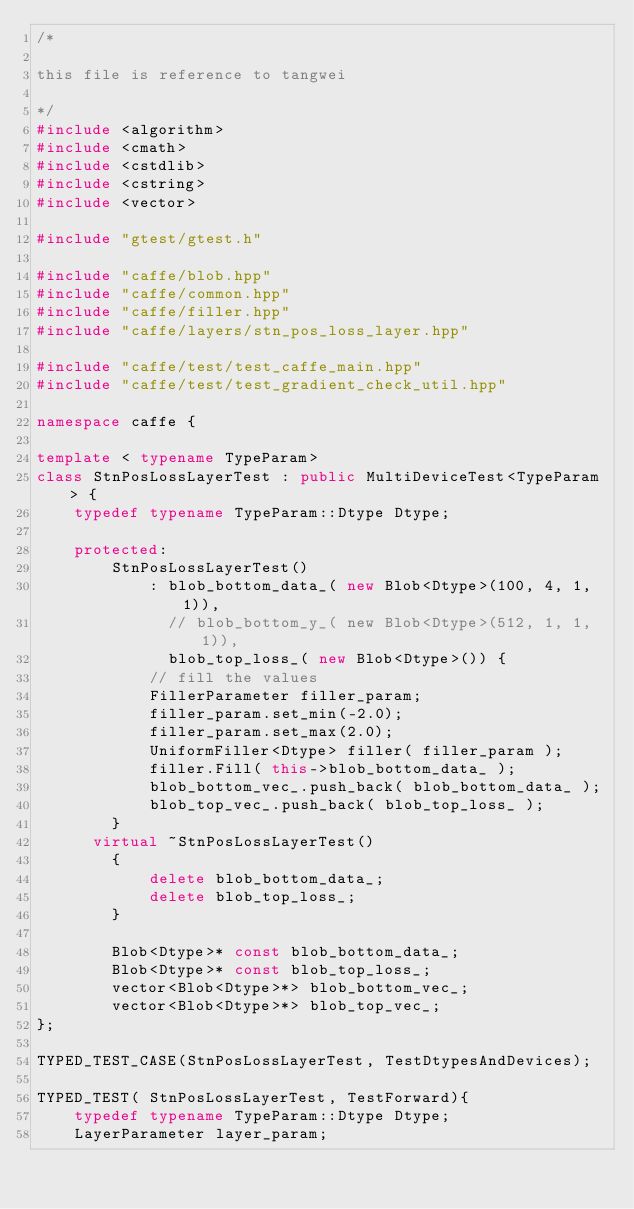Convert code to text. <code><loc_0><loc_0><loc_500><loc_500><_C++_>/*

this file is reference to tangwei

*/
#include <algorithm>
#include <cmath>
#include <cstdlib>
#include <cstring>
#include <vector>

#include "gtest/gtest.h"

#include "caffe/blob.hpp"
#include "caffe/common.hpp"
#include "caffe/filler.hpp"
#include "caffe/layers/stn_pos_loss_layer.hpp"

#include "caffe/test/test_caffe_main.hpp"
#include "caffe/test/test_gradient_check_util.hpp"

namespace caffe {

template < typename TypeParam>
class StnPosLossLayerTest : public MultiDeviceTest<TypeParam> {
    typedef typename TypeParam::Dtype Dtype;

    protected:
        StnPosLossLayerTest()
            : blob_bottom_data_( new Blob<Dtype>(100, 4, 1, 1)),
              // blob_bottom_y_( new Blob<Dtype>(512, 1, 1, 1)),
              blob_top_loss_( new Blob<Dtype>()) {
            // fill the values
            FillerParameter filler_param;
            filler_param.set_min(-2.0);
            filler_param.set_max(2.0);
            UniformFiller<Dtype> filler( filler_param );
            filler.Fill( this->blob_bottom_data_ );
            blob_bottom_vec_.push_back( blob_bottom_data_ );
            blob_top_vec_.push_back( blob_top_loss_ );
        }
      virtual ~StnPosLossLayerTest()
        {
            delete blob_bottom_data_;
            delete blob_top_loss_;
        }      

        Blob<Dtype>* const blob_bottom_data_;
        Blob<Dtype>* const blob_top_loss_;
        vector<Blob<Dtype>*> blob_bottom_vec_;
        vector<Blob<Dtype>*> blob_top_vec_;
};

TYPED_TEST_CASE(StnPosLossLayerTest, TestDtypesAndDevices);

TYPED_TEST( StnPosLossLayerTest, TestForward){
    typedef typename TypeParam::Dtype Dtype;
    LayerParameter layer_param;</code> 